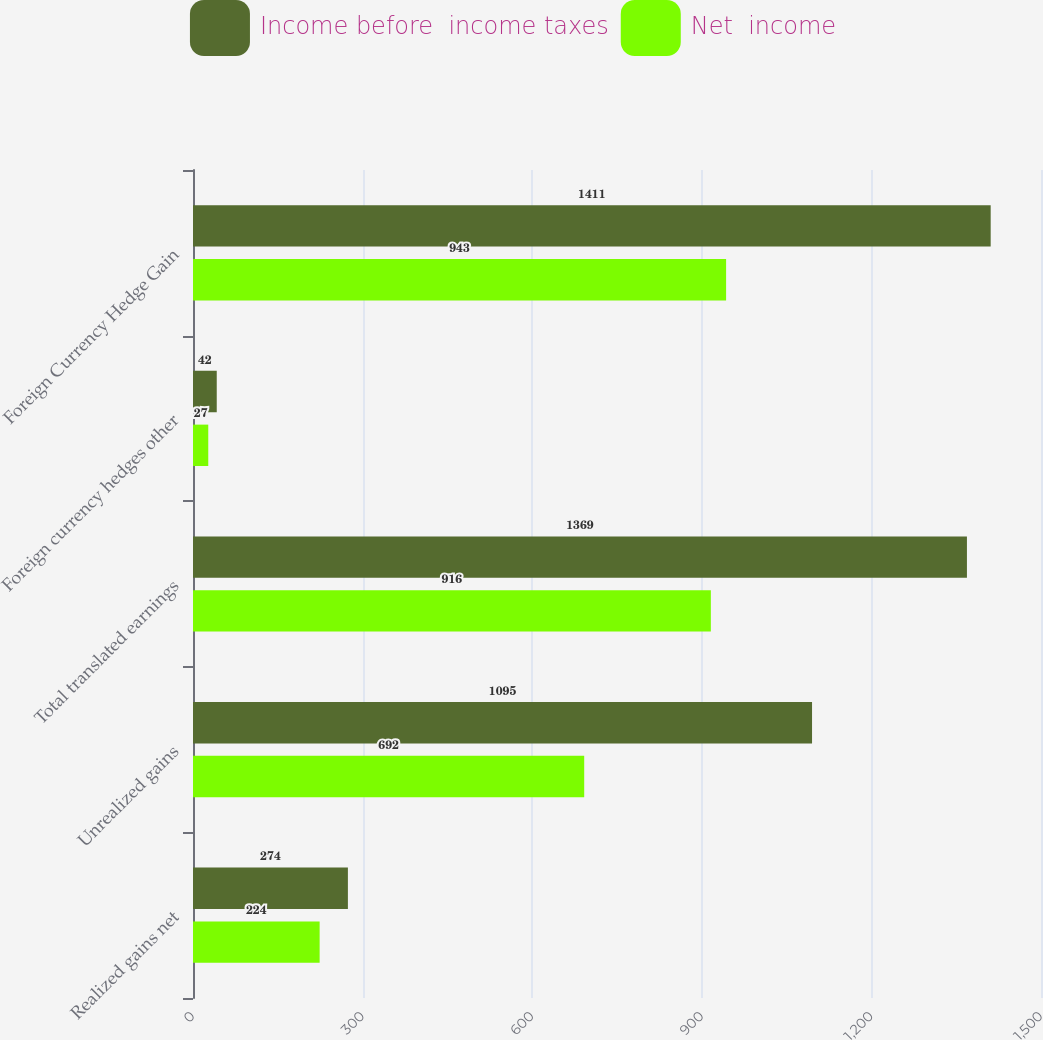Convert chart to OTSL. <chart><loc_0><loc_0><loc_500><loc_500><stacked_bar_chart><ecel><fcel>Realized gains net<fcel>Unrealized gains<fcel>Total translated earnings<fcel>Foreign currency hedges other<fcel>Foreign Currency Hedge Gain<nl><fcel>Income before  income taxes<fcel>274<fcel>1095<fcel>1369<fcel>42<fcel>1411<nl><fcel>Net  income<fcel>224<fcel>692<fcel>916<fcel>27<fcel>943<nl></chart> 